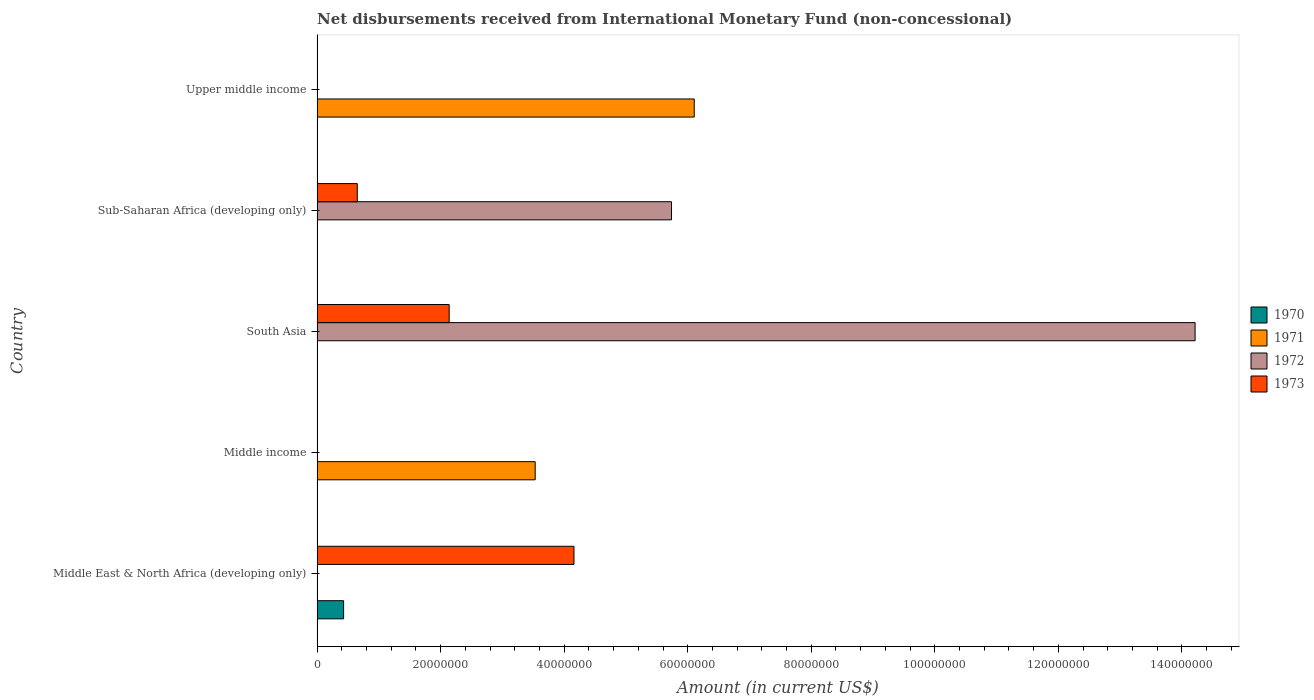How many different coloured bars are there?
Your answer should be very brief. 4. What is the label of the 2nd group of bars from the top?
Make the answer very short. Sub-Saharan Africa (developing only). What is the amount of disbursements received from International Monetary Fund in 1973 in South Asia?
Your answer should be compact. 2.14e+07. Across all countries, what is the maximum amount of disbursements received from International Monetary Fund in 1971?
Provide a short and direct response. 6.11e+07. Across all countries, what is the minimum amount of disbursements received from International Monetary Fund in 1973?
Offer a very short reply. 0. In which country was the amount of disbursements received from International Monetary Fund in 1973 maximum?
Offer a very short reply. Middle East & North Africa (developing only). What is the total amount of disbursements received from International Monetary Fund in 1970 in the graph?
Your answer should be very brief. 4.30e+06. What is the difference between the amount of disbursements received from International Monetary Fund in 1971 in Sub-Saharan Africa (developing only) and the amount of disbursements received from International Monetary Fund in 1973 in Middle East & North Africa (developing only)?
Your answer should be compact. -4.16e+07. What is the average amount of disbursements received from International Monetary Fund in 1970 per country?
Give a very brief answer. 8.60e+05. What is the difference between the amount of disbursements received from International Monetary Fund in 1972 and amount of disbursements received from International Monetary Fund in 1973 in Sub-Saharan Africa (developing only)?
Your answer should be compact. 5.09e+07. In how many countries, is the amount of disbursements received from International Monetary Fund in 1972 greater than 128000000 US$?
Ensure brevity in your answer.  1. What is the ratio of the amount of disbursements received from International Monetary Fund in 1973 in South Asia to that in Sub-Saharan Africa (developing only)?
Provide a succinct answer. 3.29. Is the amount of disbursements received from International Monetary Fund in 1973 in Middle East & North Africa (developing only) less than that in South Asia?
Your response must be concise. No. What is the difference between the highest and the lowest amount of disbursements received from International Monetary Fund in 1972?
Make the answer very short. 1.42e+08. In how many countries, is the amount of disbursements received from International Monetary Fund in 1973 greater than the average amount of disbursements received from International Monetary Fund in 1973 taken over all countries?
Offer a terse response. 2. Is it the case that in every country, the sum of the amount of disbursements received from International Monetary Fund in 1972 and amount of disbursements received from International Monetary Fund in 1973 is greater than the sum of amount of disbursements received from International Monetary Fund in 1971 and amount of disbursements received from International Monetary Fund in 1970?
Provide a short and direct response. No. Is it the case that in every country, the sum of the amount of disbursements received from International Monetary Fund in 1970 and amount of disbursements received from International Monetary Fund in 1973 is greater than the amount of disbursements received from International Monetary Fund in 1971?
Provide a succinct answer. No. How many bars are there?
Your answer should be very brief. 8. Are all the bars in the graph horizontal?
Your answer should be compact. Yes. What is the difference between two consecutive major ticks on the X-axis?
Your answer should be compact. 2.00e+07. Are the values on the major ticks of X-axis written in scientific E-notation?
Keep it short and to the point. No. Does the graph contain grids?
Keep it short and to the point. No. Where does the legend appear in the graph?
Make the answer very short. Center right. How are the legend labels stacked?
Keep it short and to the point. Vertical. What is the title of the graph?
Provide a short and direct response. Net disbursements received from International Monetary Fund (non-concessional). Does "1974" appear as one of the legend labels in the graph?
Keep it short and to the point. No. What is the label or title of the Y-axis?
Your answer should be compact. Country. What is the Amount (in current US$) of 1970 in Middle East & North Africa (developing only)?
Provide a succinct answer. 4.30e+06. What is the Amount (in current US$) in 1972 in Middle East & North Africa (developing only)?
Your response must be concise. 0. What is the Amount (in current US$) of 1973 in Middle East & North Africa (developing only)?
Your answer should be very brief. 4.16e+07. What is the Amount (in current US$) of 1971 in Middle income?
Your answer should be compact. 3.53e+07. What is the Amount (in current US$) in 1972 in Middle income?
Offer a very short reply. 0. What is the Amount (in current US$) of 1973 in Middle income?
Ensure brevity in your answer.  0. What is the Amount (in current US$) in 1970 in South Asia?
Ensure brevity in your answer.  0. What is the Amount (in current US$) in 1972 in South Asia?
Ensure brevity in your answer.  1.42e+08. What is the Amount (in current US$) of 1973 in South Asia?
Your answer should be very brief. 2.14e+07. What is the Amount (in current US$) in 1970 in Sub-Saharan Africa (developing only)?
Provide a short and direct response. 0. What is the Amount (in current US$) in 1972 in Sub-Saharan Africa (developing only)?
Provide a succinct answer. 5.74e+07. What is the Amount (in current US$) of 1973 in Sub-Saharan Africa (developing only)?
Ensure brevity in your answer.  6.51e+06. What is the Amount (in current US$) in 1971 in Upper middle income?
Make the answer very short. 6.11e+07. Across all countries, what is the maximum Amount (in current US$) in 1970?
Offer a terse response. 4.30e+06. Across all countries, what is the maximum Amount (in current US$) of 1971?
Ensure brevity in your answer.  6.11e+07. Across all countries, what is the maximum Amount (in current US$) of 1972?
Provide a short and direct response. 1.42e+08. Across all countries, what is the maximum Amount (in current US$) of 1973?
Keep it short and to the point. 4.16e+07. Across all countries, what is the minimum Amount (in current US$) of 1970?
Offer a very short reply. 0. Across all countries, what is the minimum Amount (in current US$) in 1972?
Provide a short and direct response. 0. What is the total Amount (in current US$) of 1970 in the graph?
Offer a very short reply. 4.30e+06. What is the total Amount (in current US$) in 1971 in the graph?
Keep it short and to the point. 9.64e+07. What is the total Amount (in current US$) in 1972 in the graph?
Your answer should be very brief. 2.00e+08. What is the total Amount (in current US$) in 1973 in the graph?
Provide a short and direct response. 6.95e+07. What is the difference between the Amount (in current US$) in 1973 in Middle East & North Africa (developing only) and that in South Asia?
Your answer should be compact. 2.02e+07. What is the difference between the Amount (in current US$) in 1973 in Middle East & North Africa (developing only) and that in Sub-Saharan Africa (developing only)?
Give a very brief answer. 3.51e+07. What is the difference between the Amount (in current US$) in 1971 in Middle income and that in Upper middle income?
Your answer should be compact. -2.57e+07. What is the difference between the Amount (in current US$) in 1972 in South Asia and that in Sub-Saharan Africa (developing only)?
Provide a succinct answer. 8.48e+07. What is the difference between the Amount (in current US$) in 1973 in South Asia and that in Sub-Saharan Africa (developing only)?
Make the answer very short. 1.49e+07. What is the difference between the Amount (in current US$) in 1970 in Middle East & North Africa (developing only) and the Amount (in current US$) in 1971 in Middle income?
Your answer should be very brief. -3.10e+07. What is the difference between the Amount (in current US$) in 1970 in Middle East & North Africa (developing only) and the Amount (in current US$) in 1972 in South Asia?
Make the answer very short. -1.38e+08. What is the difference between the Amount (in current US$) of 1970 in Middle East & North Africa (developing only) and the Amount (in current US$) of 1973 in South Asia?
Offer a terse response. -1.71e+07. What is the difference between the Amount (in current US$) of 1970 in Middle East & North Africa (developing only) and the Amount (in current US$) of 1972 in Sub-Saharan Africa (developing only)?
Your answer should be very brief. -5.31e+07. What is the difference between the Amount (in current US$) in 1970 in Middle East & North Africa (developing only) and the Amount (in current US$) in 1973 in Sub-Saharan Africa (developing only)?
Ensure brevity in your answer.  -2.21e+06. What is the difference between the Amount (in current US$) in 1970 in Middle East & North Africa (developing only) and the Amount (in current US$) in 1971 in Upper middle income?
Ensure brevity in your answer.  -5.68e+07. What is the difference between the Amount (in current US$) of 1971 in Middle income and the Amount (in current US$) of 1972 in South Asia?
Offer a terse response. -1.07e+08. What is the difference between the Amount (in current US$) in 1971 in Middle income and the Amount (in current US$) in 1973 in South Asia?
Provide a short and direct response. 1.39e+07. What is the difference between the Amount (in current US$) in 1971 in Middle income and the Amount (in current US$) in 1972 in Sub-Saharan Africa (developing only)?
Offer a very short reply. -2.21e+07. What is the difference between the Amount (in current US$) in 1971 in Middle income and the Amount (in current US$) in 1973 in Sub-Saharan Africa (developing only)?
Your answer should be compact. 2.88e+07. What is the difference between the Amount (in current US$) in 1972 in South Asia and the Amount (in current US$) in 1973 in Sub-Saharan Africa (developing only)?
Provide a short and direct response. 1.36e+08. What is the average Amount (in current US$) of 1970 per country?
Your answer should be very brief. 8.60e+05. What is the average Amount (in current US$) in 1971 per country?
Keep it short and to the point. 1.93e+07. What is the average Amount (in current US$) in 1972 per country?
Your answer should be compact. 3.99e+07. What is the average Amount (in current US$) in 1973 per country?
Your response must be concise. 1.39e+07. What is the difference between the Amount (in current US$) in 1970 and Amount (in current US$) in 1973 in Middle East & North Africa (developing only)?
Ensure brevity in your answer.  -3.73e+07. What is the difference between the Amount (in current US$) in 1972 and Amount (in current US$) in 1973 in South Asia?
Keep it short and to the point. 1.21e+08. What is the difference between the Amount (in current US$) in 1972 and Amount (in current US$) in 1973 in Sub-Saharan Africa (developing only)?
Your answer should be very brief. 5.09e+07. What is the ratio of the Amount (in current US$) in 1973 in Middle East & North Africa (developing only) to that in South Asia?
Offer a very short reply. 1.94. What is the ratio of the Amount (in current US$) of 1973 in Middle East & North Africa (developing only) to that in Sub-Saharan Africa (developing only)?
Keep it short and to the point. 6.39. What is the ratio of the Amount (in current US$) of 1971 in Middle income to that in Upper middle income?
Provide a short and direct response. 0.58. What is the ratio of the Amount (in current US$) in 1972 in South Asia to that in Sub-Saharan Africa (developing only)?
Provide a short and direct response. 2.48. What is the ratio of the Amount (in current US$) of 1973 in South Asia to that in Sub-Saharan Africa (developing only)?
Offer a terse response. 3.29. What is the difference between the highest and the second highest Amount (in current US$) of 1973?
Offer a very short reply. 2.02e+07. What is the difference between the highest and the lowest Amount (in current US$) in 1970?
Give a very brief answer. 4.30e+06. What is the difference between the highest and the lowest Amount (in current US$) of 1971?
Ensure brevity in your answer.  6.11e+07. What is the difference between the highest and the lowest Amount (in current US$) of 1972?
Keep it short and to the point. 1.42e+08. What is the difference between the highest and the lowest Amount (in current US$) in 1973?
Keep it short and to the point. 4.16e+07. 